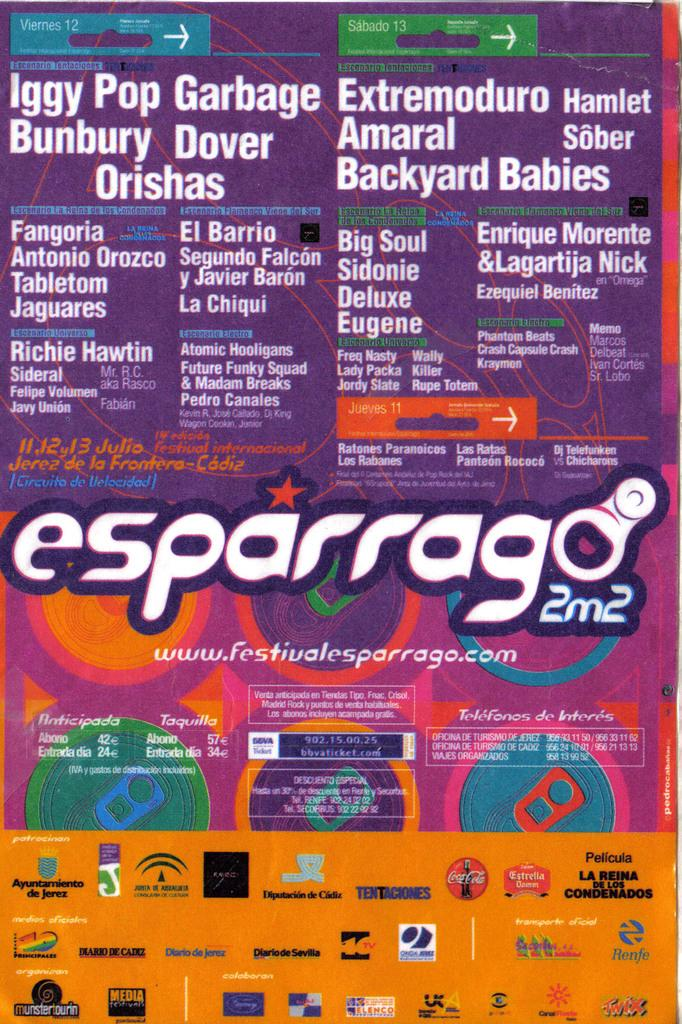Provide a one-sentence caption for the provided image. Posterfor Iggy Pop Garbage that has a Coca Cola logo on the bottom. 